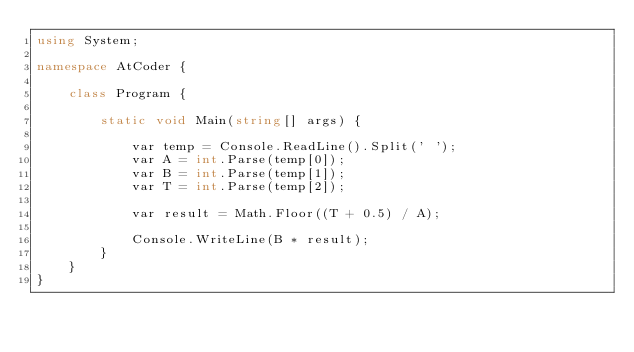<code> <loc_0><loc_0><loc_500><loc_500><_C#_>using System;

namespace AtCoder {

    class Program {

        static void Main(string[] args) {

            var temp = Console.ReadLine().Split(' ');
            var A = int.Parse(temp[0]);
            var B = int.Parse(temp[1]);
            var T = int.Parse(temp[2]);

            var result = Math.Floor((T + 0.5) / A);

            Console.WriteLine(B * result);
        }
    }
}
</code> 